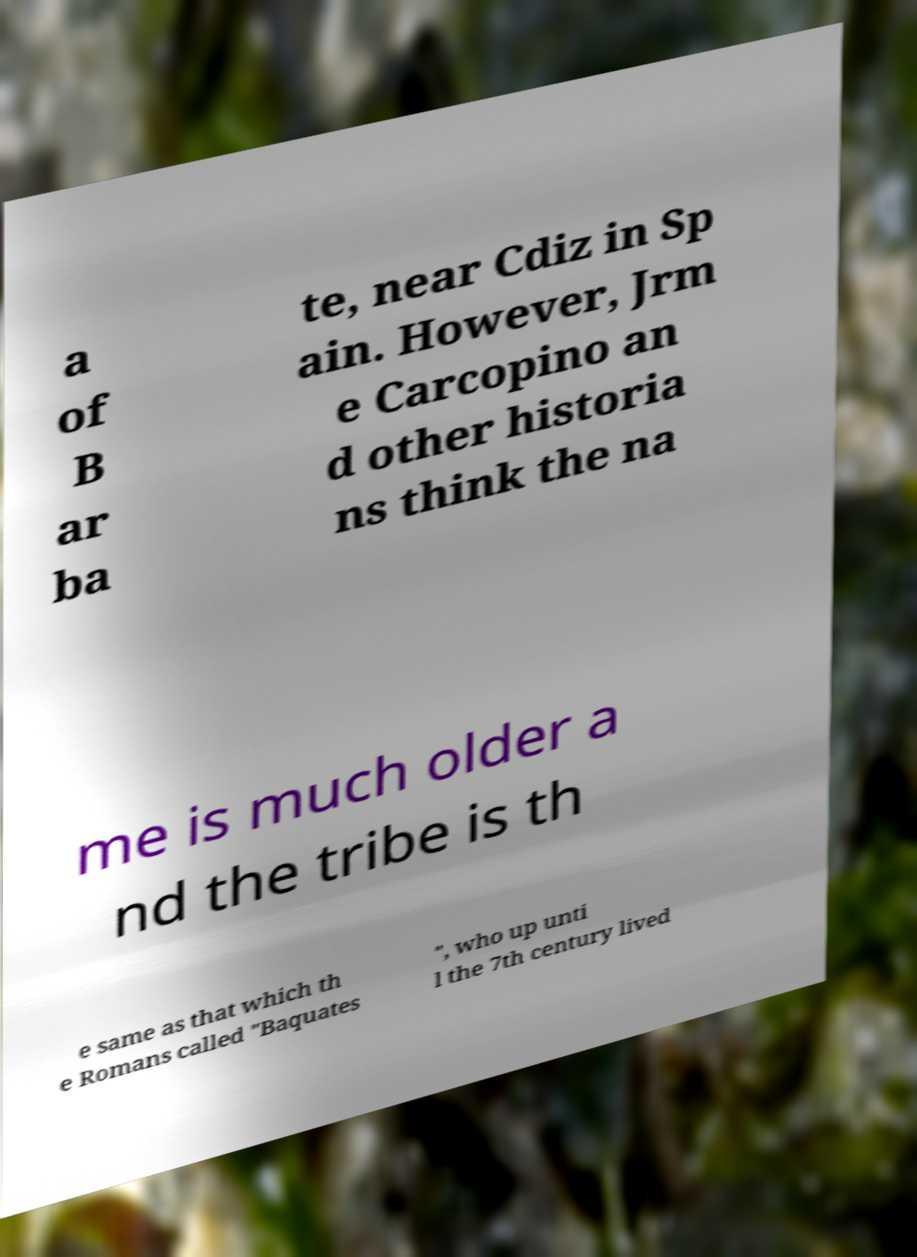There's text embedded in this image that I need extracted. Can you transcribe it verbatim? a of B ar ba te, near Cdiz in Sp ain. However, Jrm e Carcopino an d other historia ns think the na me is much older a nd the tribe is th e same as that which th e Romans called "Baquates ", who up unti l the 7th century lived 